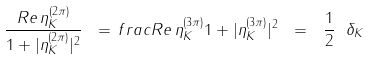<formula> <loc_0><loc_0><loc_500><loc_500>\frac { R e \, \eta _ { K } ^ { ( 2 \pi ) } } { 1 + | \eta _ { K } ^ { ( 2 \pi ) } | ^ { 2 } } \ = \, f r a c { R e \, \eta _ { K } ^ { ( 3 \pi ) } } { 1 + | \eta _ { K } ^ { ( 3 \pi ) } | ^ { 2 } } \ = \ \frac { 1 } { 2 } \ \delta _ { K }</formula> 